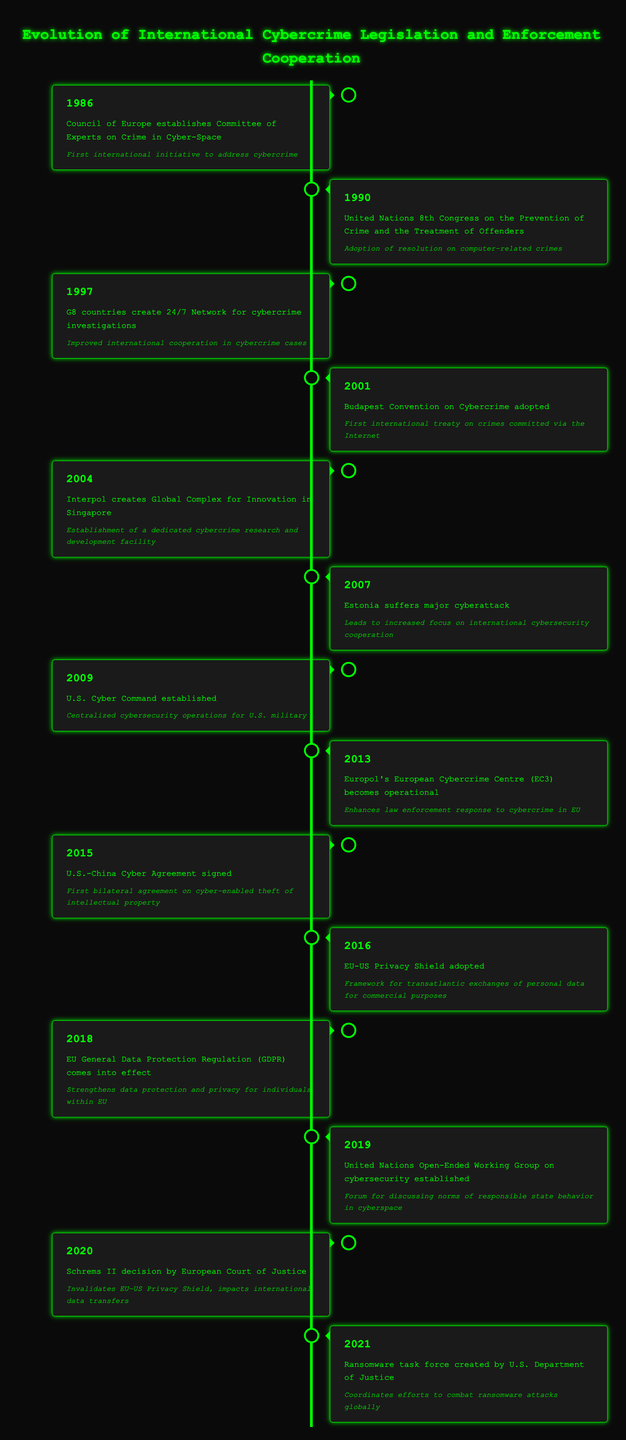What event was the first international initiative to address cybercrime? The table states that the "Council of Europe establishes Committee of Experts on Crime in Cyber-Space" in 1986 was the first international initiative to address cybercrime.
Answer: Council of Europe establishes Committee of Experts on Crime in Cyber-Space Which year did the Budapest Convention on Cybercrime get adopted? According to the timeline, the Budapest Convention on Cybercrime was adopted in 2001.
Answer: 2001 Were there any significant events related to cybercrime in 2019? The table lists one event in 2019: "United Nations Open-Ended Working Group on cybersecurity established," which indicates there was a significant event that year.
Answer: Yes What is the significance of the U.S.-China Cyber Agreement signed in 2015? The event description states that it is the "First bilateral agreement on cyber-enabled theft of intellectual property," highlighting its importance in international cybercrime legislation.
Answer: First bilateral agreement on cyber-enabled theft of intellectual property How many years passed between the establishment of the Committee of Experts on Crime in Cyber-Space and the adoption of the Budapest Convention? To find this, we subtract 1986 from 2001, which gives us 15 years between the two events.
Answer: 15 years Which event led to an increased focus on international cybersecurity cooperation? In the timeline, the event "Estonia suffers major cyberattack" in 2007 is noted as leading to increased focus on international cybersecurity cooperation.
Answer: Estonia suffers major cyberattack Is it true that the GDPR came into effect before the EU-US Privacy Shield was adopted? The timeline shows that GDPR came into effect in 2018 and the EU-US Privacy Shield was adopted in 2016, making the statement false.
Answer: No How many international cybercrime initiatives were established from 1986 to 2015? From the years listed, initiatives include 1986, 1990, 1997, 2001, 2004, and 2015. Counting these gives a total of 6 initiatives established.
Answer: 6 initiatives 